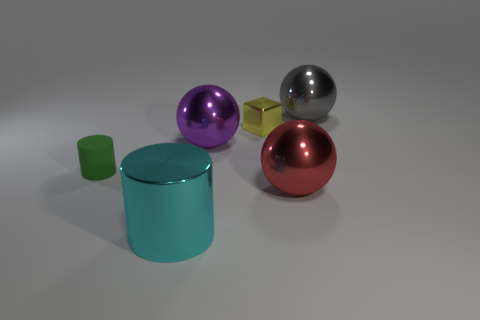Add 4 tiny metallic cylinders. How many objects exist? 10 Subtract all cubes. How many objects are left? 5 Subtract 0 brown cylinders. How many objects are left? 6 Subtract all big gray things. Subtract all big shiny cylinders. How many objects are left? 4 Add 3 big cyan objects. How many big cyan objects are left? 4 Add 5 large brown cylinders. How many large brown cylinders exist? 5 